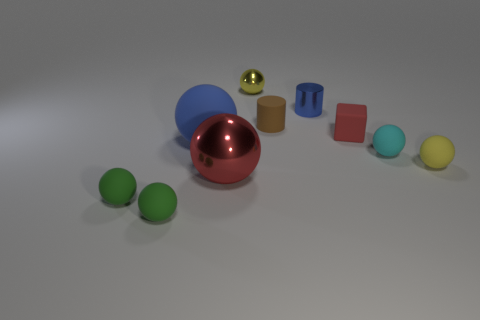There is a yellow object that is in front of the yellow sphere that is on the left side of the small yellow sphere that is to the right of the cyan matte object; what is its size?
Offer a very short reply. Small. There is a tiny yellow rubber thing; does it have the same shape as the yellow object that is on the left side of the cyan matte thing?
Ensure brevity in your answer.  Yes. How many things are both right of the brown thing and behind the blue sphere?
Keep it short and to the point. 2. How many green things are either shiny balls or small matte blocks?
Offer a terse response. 0. Is the color of the cylinder on the left side of the small blue thing the same as the big thing that is in front of the big rubber sphere?
Your answer should be compact. No. There is a shiny thing in front of the big sphere behind the small yellow sphere that is in front of the tiny cyan thing; what color is it?
Offer a very short reply. Red. There is a yellow thing behind the large blue matte object; are there any small red rubber objects left of it?
Ensure brevity in your answer.  No. There is a metal object in front of the large rubber object; does it have the same shape as the tiny red rubber thing?
Provide a succinct answer. No. Is there anything else that has the same shape as the small brown object?
Your response must be concise. Yes. What number of balls are cyan rubber objects or matte objects?
Make the answer very short. 5. 